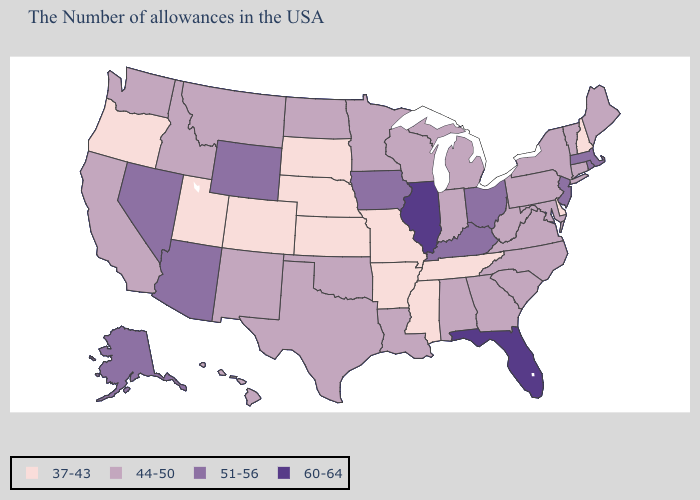Which states have the highest value in the USA?
Write a very short answer. Florida, Illinois. What is the lowest value in states that border West Virginia?
Write a very short answer. 44-50. What is the value of Maryland?
Concise answer only. 44-50. What is the value of Kansas?
Give a very brief answer. 37-43. What is the value of Michigan?
Concise answer only. 44-50. What is the value of South Carolina?
Be succinct. 44-50. Name the states that have a value in the range 37-43?
Write a very short answer. New Hampshire, Delaware, Tennessee, Mississippi, Missouri, Arkansas, Kansas, Nebraska, South Dakota, Colorado, Utah, Oregon. Does Florida have the same value as Illinois?
Concise answer only. Yes. Name the states that have a value in the range 51-56?
Short answer required. Massachusetts, Rhode Island, New Jersey, Ohio, Kentucky, Iowa, Wyoming, Arizona, Nevada, Alaska. Among the states that border California , which have the lowest value?
Quick response, please. Oregon. Name the states that have a value in the range 37-43?
Be succinct. New Hampshire, Delaware, Tennessee, Mississippi, Missouri, Arkansas, Kansas, Nebraska, South Dakota, Colorado, Utah, Oregon. Name the states that have a value in the range 37-43?
Short answer required. New Hampshire, Delaware, Tennessee, Mississippi, Missouri, Arkansas, Kansas, Nebraska, South Dakota, Colorado, Utah, Oregon. What is the value of Oregon?
Short answer required. 37-43. What is the value of California?
Quick response, please. 44-50. 